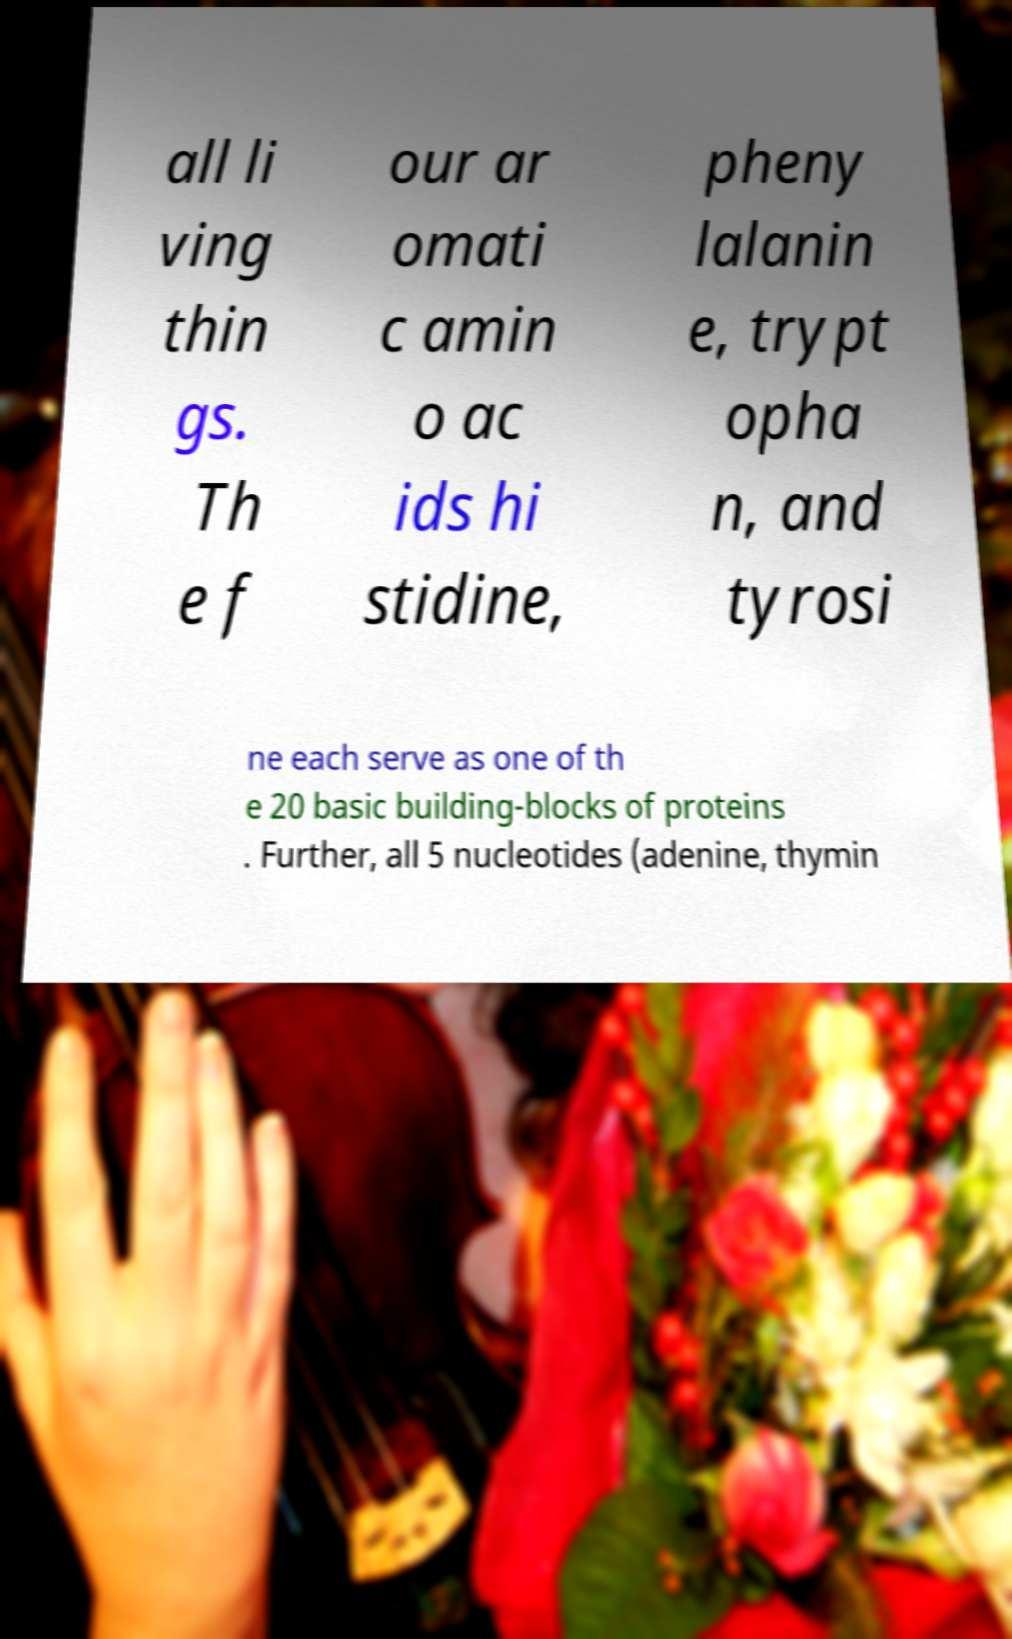Could you extract and type out the text from this image? all li ving thin gs. Th e f our ar omati c amin o ac ids hi stidine, pheny lalanin e, trypt opha n, and tyrosi ne each serve as one of th e 20 basic building-blocks of proteins . Further, all 5 nucleotides (adenine, thymin 